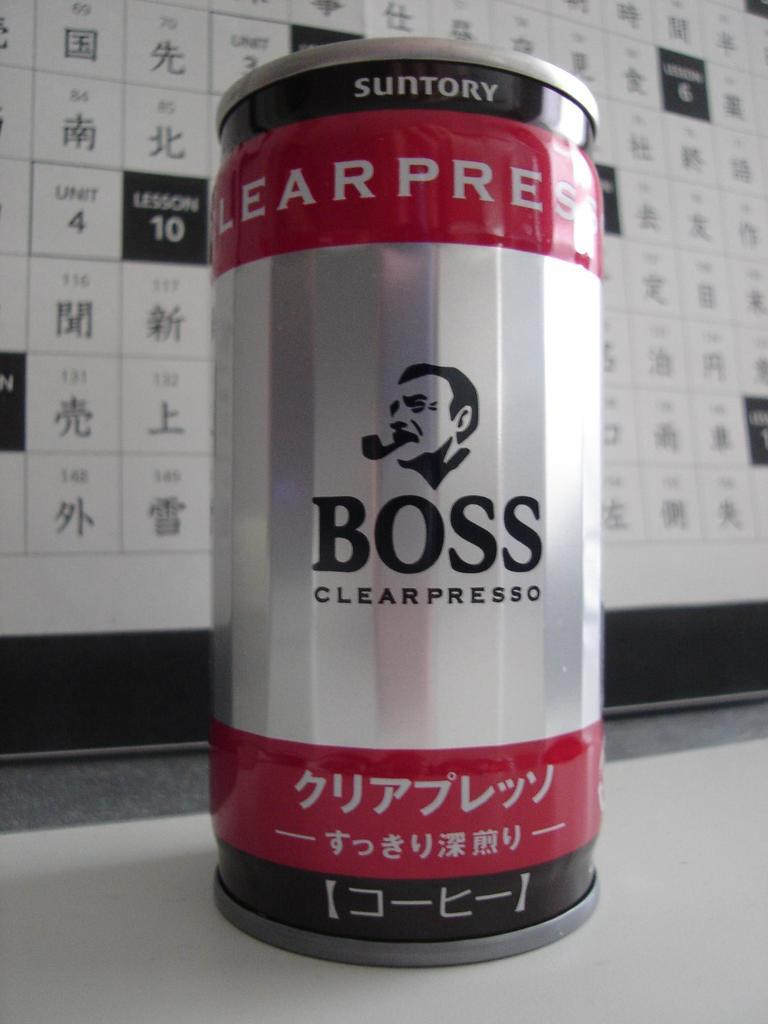<image>
Relay a brief, clear account of the picture shown. A can of Boss Clearpresso on a table. 